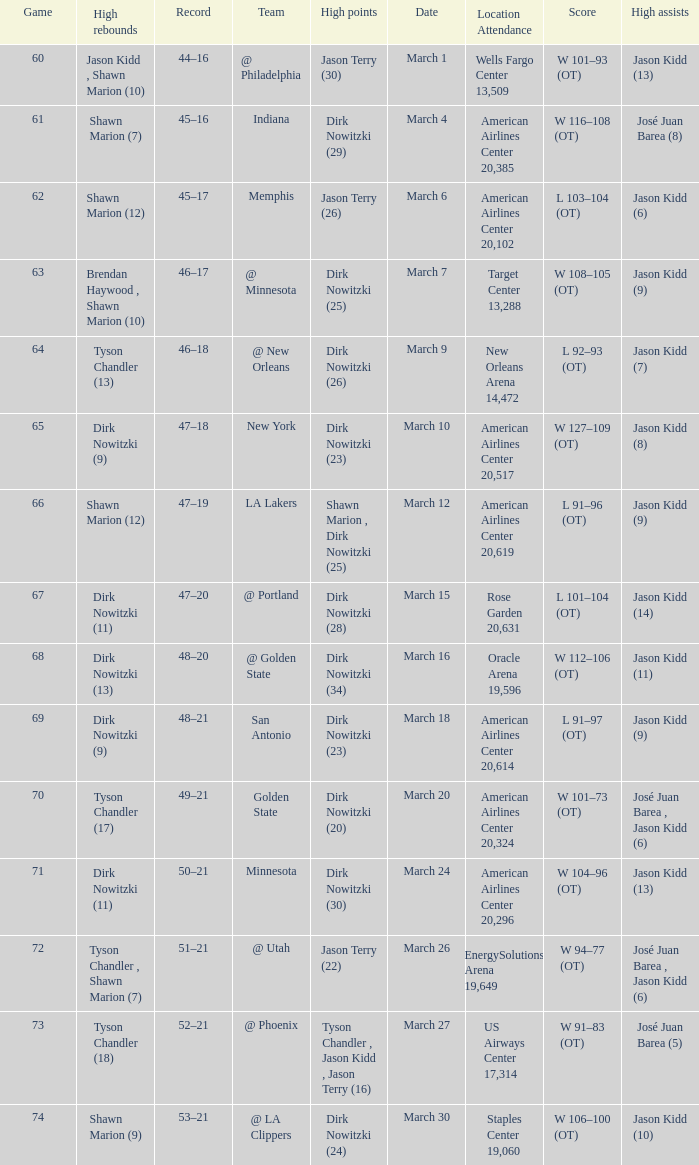Name the score for  josé juan barea (8) W 116–108 (OT). 